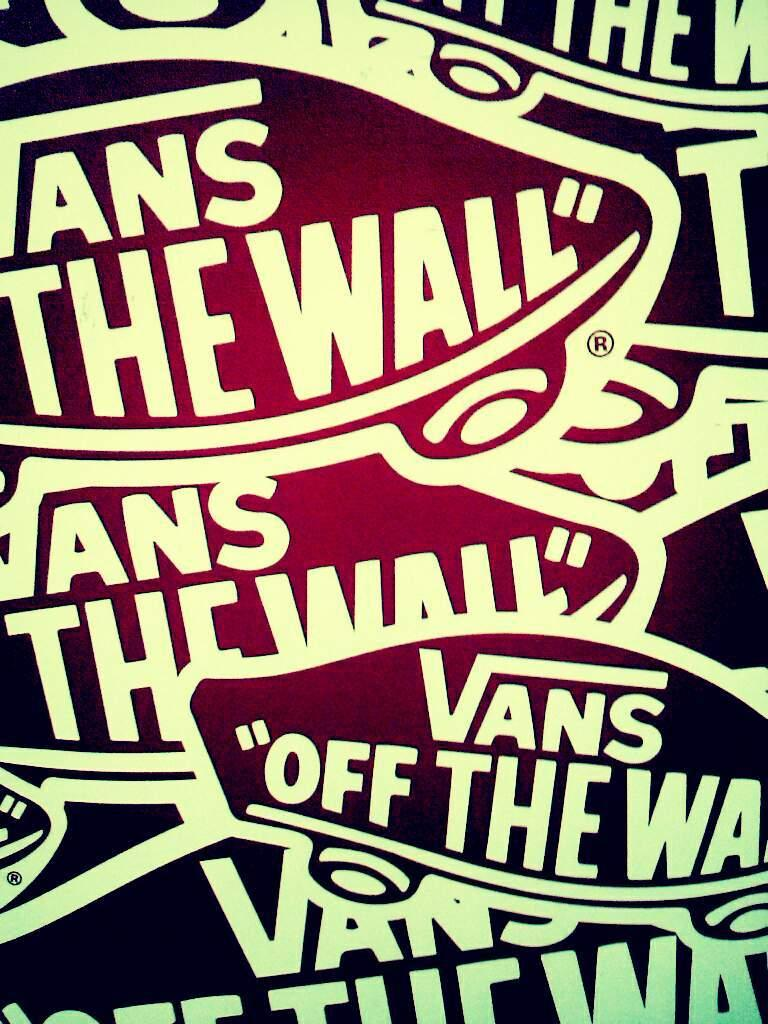What can be seen in the image? There are designs and texts in the image. Where are the designs and texts located? The designs and texts are on a platform. How many ears of corn are visible in the image? There are no ears of corn present in the image. What type of mice can be seen interacting with the designs in the image? There are no mice present in the image; it only features designs and texts on a platform. 